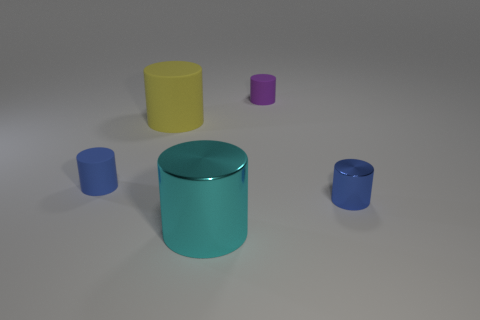There is a yellow object; does it have the same size as the blue cylinder on the right side of the small blue rubber object?
Your answer should be compact. No. There is a metal thing that is to the left of the tiny metallic cylinder; is it the same size as the blue thing to the left of the small blue shiny cylinder?
Your answer should be very brief. No. Is there a small blue thing in front of the small blue cylinder behind the blue shiny cylinder?
Make the answer very short. Yes. Are there an equal number of tiny objects behind the purple cylinder and small matte spheres?
Offer a terse response. Yes. What number of other things are the same size as the cyan cylinder?
Your answer should be very brief. 1. Are the blue cylinder right of the blue rubber object and the object in front of the small metal cylinder made of the same material?
Your answer should be very brief. Yes. How big is the metal thing that is to the right of the tiny purple thing that is behind the large cyan cylinder?
Provide a succinct answer. Small. Are there any cylinders that have the same color as the tiny shiny object?
Provide a succinct answer. Yes. There is a thing on the left side of the big rubber object; is it the same color as the shiny object to the right of the purple object?
Give a very brief answer. Yes. How many small rubber things are behind the blue rubber cylinder?
Offer a very short reply. 1. 